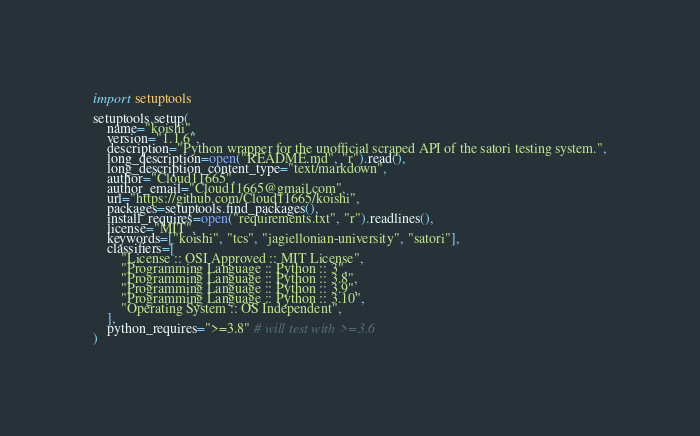Convert code to text. <code><loc_0><loc_0><loc_500><loc_500><_Python_>import setuptools

setuptools.setup(
	name="koishi",
	version="1.1.6",
	description="Python wrapper for the unofficial scraped API of the satori testing system.",
	long_description=open("README.md", "r").read(),
	long_description_content_type="text/markdown",
	author="Cloud11665",
	author_email="Cloud11665@gmail.com",
	url="https://github.com/Cloud11665/koishi",
	packages=setuptools.find_packages(),
	install_requires=open("requirements.txt", "r").readlines(),
	license="MIT",
	keywords=["koishi", "tcs", "jagiellonian-university", "satori"],
	classifiers=[
		"License :: OSI Approved :: MIT License",
		"Programming Language :: Python :: 3",
		"Programming Language :: Python :: 3.8",
		"Programming Language :: Python :: 3.9",
		"Programming Language :: Python :: 3.10",
		"Operating System :: OS Independent",
	],
	python_requires=">=3.8" # will test with >=3.6
)</code> 